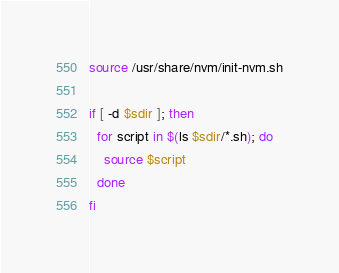<code> <loc_0><loc_0><loc_500><loc_500><_Bash_>source /usr/share/nvm/init-nvm.sh

if [ -d $sdir ]; then
  for script in $(ls $sdir/*.sh); do
    source $script
  done
fi

</code> 